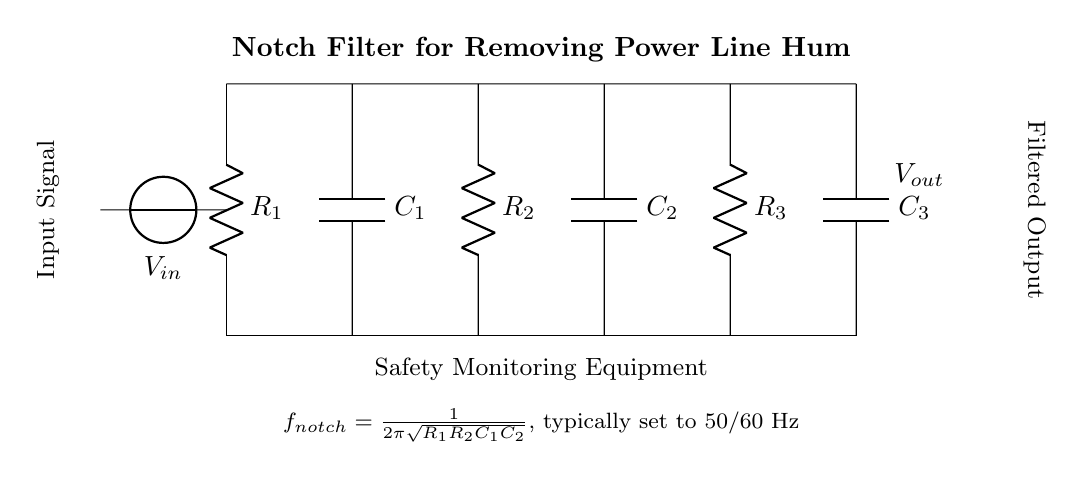What is the type of filter shown? The circuit diagram depicts a notch filter, which is specifically designed to eliminate unwanted frequencies from a signal. It is characterized by its ability to "notch out" a specific frequency, most commonly the power line hum at 50 or 60 Hz.
Answer: Notch filter What is the purpose of the capacitors in this circuit? The capacitors in a notch filter help form an LC resonance circuit that targets the specific frequency to be removed, allowing other frequencies to pass through while blocking the unwanted frequency. In this case, they work with the resistors to create the notch effect at the desired frequency.
Answer: Block unwanted frequency What is the input voltage source labeled as? The voltage source in the diagram is labeled as V_in, which indicates it is the input signal fed into the filter for processing.
Answer: V_in What is the formula for the notch frequency? The formula provided in the circuit diagram for the notch frequency is f_notch = (1/(2π√(R1R2C1C2))). This formula relates the resistors and capacitors in the circuit to the frequency that will be eliminated.
Answer: f_notch = 1/(2π√(R1R2C1C2)) How many resistors are present in the circuit? The circuit includes three resistors, which are R1, R2, and R3, as shown in the diagram representing a component configuration that aids in shaping the filter characteristics.
Answer: Three What is the output labeled as? The output is labeled as V_out, indicating that it is the filtered output signal after the input has passed through the notch filter, effectively removing the power line hum.
Answer: V_out 